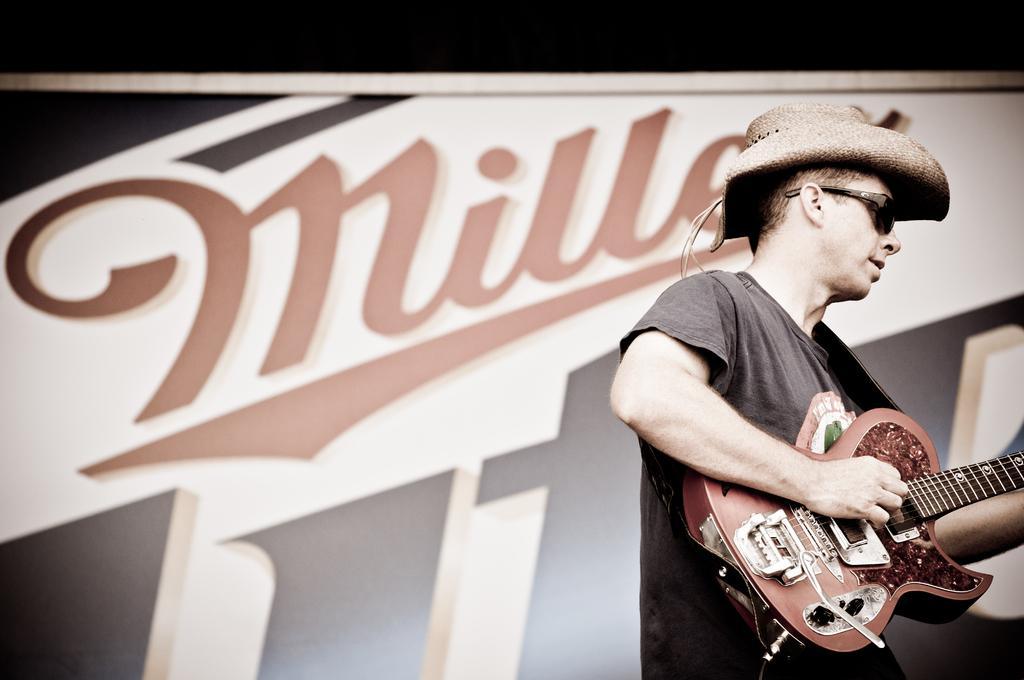Could you give a brief overview of what you see in this image? Here we can see a man playing guitar. He has goggles and he wore a cap. In the background there is a banner. 